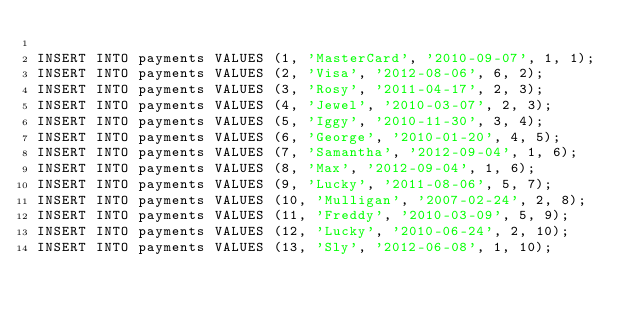Convert code to text. <code><loc_0><loc_0><loc_500><loc_500><_SQL_>
INSERT INTO payments VALUES (1, 'MasterCard', '2010-09-07', 1, 1);
INSERT INTO payments VALUES (2, 'Visa', '2012-08-06', 6, 2);
INSERT INTO payments VALUES (3, 'Rosy', '2011-04-17', 2, 3);
INSERT INTO payments VALUES (4, 'Jewel', '2010-03-07', 2, 3);
INSERT INTO payments VALUES (5, 'Iggy', '2010-11-30', 3, 4);
INSERT INTO payments VALUES (6, 'George', '2010-01-20', 4, 5);
INSERT INTO payments VALUES (7, 'Samantha', '2012-09-04', 1, 6);
INSERT INTO payments VALUES (8, 'Max', '2012-09-04', 1, 6);
INSERT INTO payments VALUES (9, 'Lucky', '2011-08-06', 5, 7);
INSERT INTO payments VALUES (10, 'Mulligan', '2007-02-24', 2, 8);
INSERT INTO payments VALUES (11, 'Freddy', '2010-03-09', 5, 9);
INSERT INTO payments VALUES (12, 'Lucky', '2010-06-24', 2, 10);
INSERT INTO payments VALUES (13, 'Sly', '2012-06-08', 1, 10);
</code> 